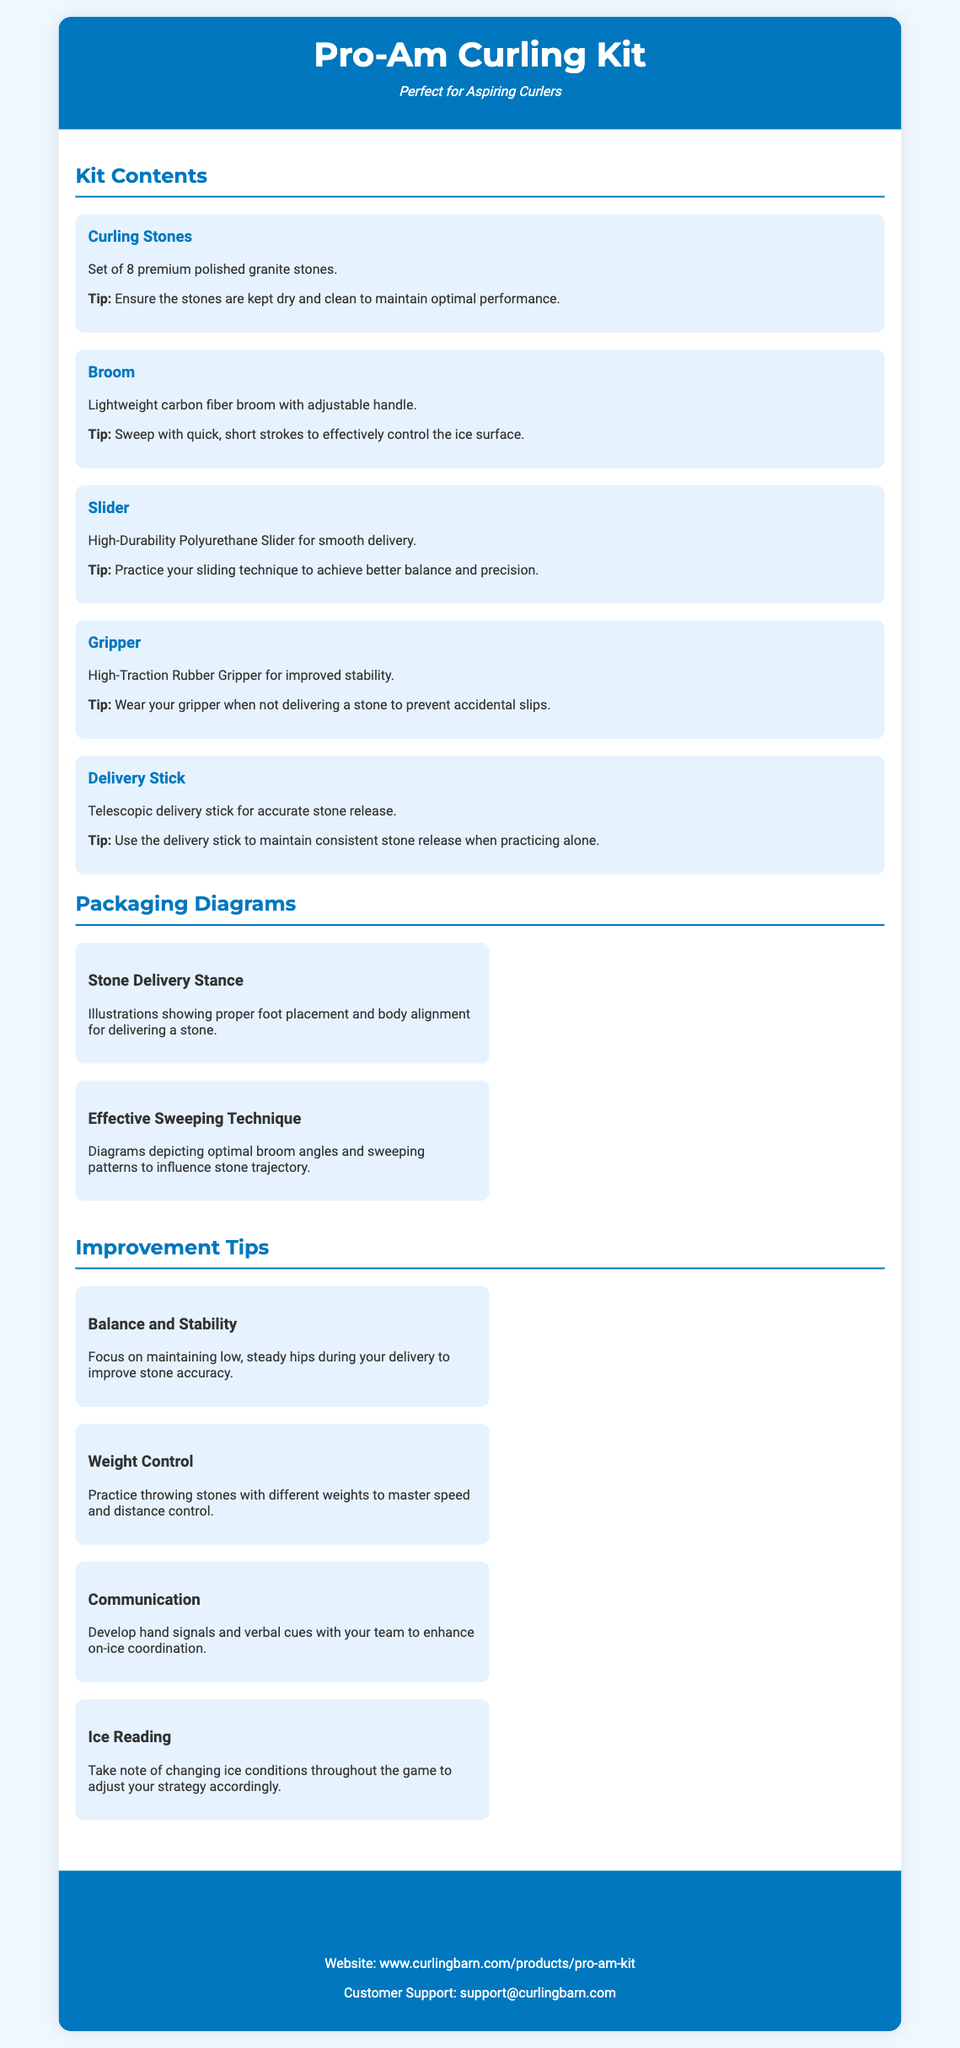What is the product name? The product name is stated in the header of the document.
Answer: Pro-Am Curling Kit How many curling stones are included in the kit? The number of curling stones is mentioned in the "Kit Contents" section.
Answer: 8 What material is the broom made of? The material of the broom is detailed in the description under "Broom."
Answer: Carbon fiber What does the high-durability slider provide? The function of the slider is described in its information section.
Answer: Smooth delivery What is a suggested technique for sweeping? Tips for effective sweeping are provided in the "Broom" section.
Answer: Quick, short strokes Which diagram focuses on body alignment? The specific diagrams are listed under "Packaging Diagrams."
Answer: Stone Delivery Stance What does the tip for balance and stability focus on? The content of the improvement tip is stated directly in the document.
Answer: Low, steady hips How can curlers improve team communication? The method to enhance communication is explained within the improvement tips.
Answer: Hand signals and verbal cues What type of contact support is provided in the packaging? The section titled "Contact Information" lists ways to reach out.
Answer: Customer Support 